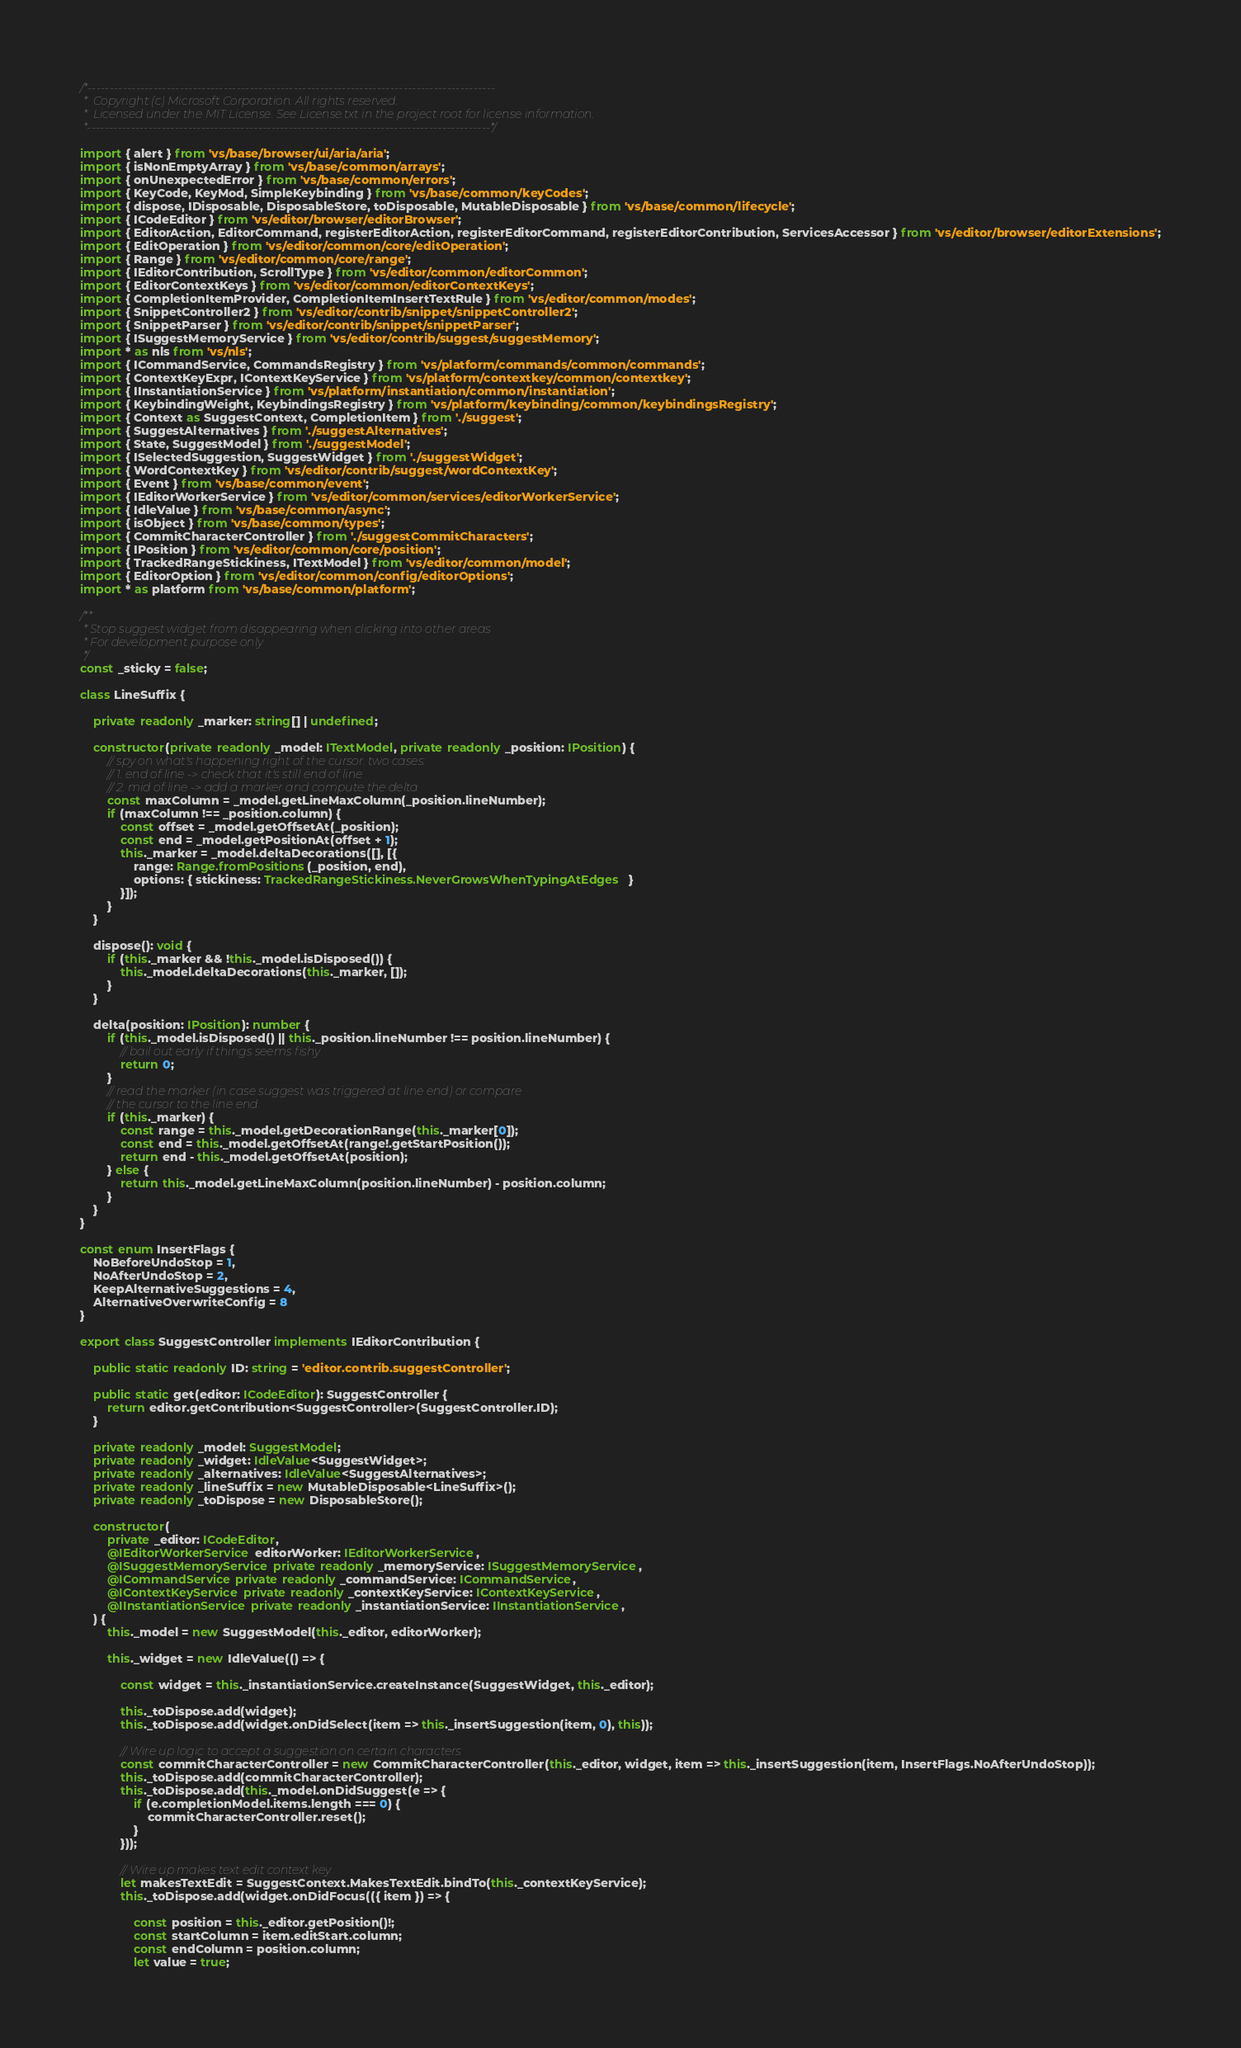<code> <loc_0><loc_0><loc_500><loc_500><_TypeScript_>/*---------------------------------------------------------------------------------------------
 *  Copyright (c) Microsoft Corporation. All rights reserved.
 *  Licensed under the MIT License. See License.txt in the project root for license information.
 *--------------------------------------------------------------------------------------------*/

import { alert } from 'vs/base/browser/ui/aria/aria';
import { isNonEmptyArray } from 'vs/base/common/arrays';
import { onUnexpectedError } from 'vs/base/common/errors';
import { KeyCode, KeyMod, SimpleKeybinding } from 'vs/base/common/keyCodes';
import { dispose, IDisposable, DisposableStore, toDisposable, MutableDisposable } from 'vs/base/common/lifecycle';
import { ICodeEditor } from 'vs/editor/browser/editorBrowser';
import { EditorAction, EditorCommand, registerEditorAction, registerEditorCommand, registerEditorContribution, ServicesAccessor } from 'vs/editor/browser/editorExtensions';
import { EditOperation } from 'vs/editor/common/core/editOperation';
import { Range } from 'vs/editor/common/core/range';
import { IEditorContribution, ScrollType } from 'vs/editor/common/editorCommon';
import { EditorContextKeys } from 'vs/editor/common/editorContextKeys';
import { CompletionItemProvider, CompletionItemInsertTextRule } from 'vs/editor/common/modes';
import { SnippetController2 } from 'vs/editor/contrib/snippet/snippetController2';
import { SnippetParser } from 'vs/editor/contrib/snippet/snippetParser';
import { ISuggestMemoryService } from 'vs/editor/contrib/suggest/suggestMemory';
import * as nls from 'vs/nls';
import { ICommandService, CommandsRegistry } from 'vs/platform/commands/common/commands';
import { ContextKeyExpr, IContextKeyService } from 'vs/platform/contextkey/common/contextkey';
import { IInstantiationService } from 'vs/platform/instantiation/common/instantiation';
import { KeybindingWeight, KeybindingsRegistry } from 'vs/platform/keybinding/common/keybindingsRegistry';
import { Context as SuggestContext, CompletionItem } from './suggest';
import { SuggestAlternatives } from './suggestAlternatives';
import { State, SuggestModel } from './suggestModel';
import { ISelectedSuggestion, SuggestWidget } from './suggestWidget';
import { WordContextKey } from 'vs/editor/contrib/suggest/wordContextKey';
import { Event } from 'vs/base/common/event';
import { IEditorWorkerService } from 'vs/editor/common/services/editorWorkerService';
import { IdleValue } from 'vs/base/common/async';
import { isObject } from 'vs/base/common/types';
import { CommitCharacterController } from './suggestCommitCharacters';
import { IPosition } from 'vs/editor/common/core/position';
import { TrackedRangeStickiness, ITextModel } from 'vs/editor/common/model';
import { EditorOption } from 'vs/editor/common/config/editorOptions';
import * as platform from 'vs/base/common/platform';

/**
 * Stop suggest widget from disappearing when clicking into other areas
 * For development purpose only
 */
const _sticky = false;

class LineSuffix {

	private readonly _marker: string[] | undefined;

	constructor(private readonly _model: ITextModel, private readonly _position: IPosition) {
		// spy on what's happening right of the cursor. two cases:
		// 1. end of line -> check that it's still end of line
		// 2. mid of line -> add a marker and compute the delta
		const maxColumn = _model.getLineMaxColumn(_position.lineNumber);
		if (maxColumn !== _position.column) {
			const offset = _model.getOffsetAt(_position);
			const end = _model.getPositionAt(offset + 1);
			this._marker = _model.deltaDecorations([], [{
				range: Range.fromPositions(_position, end),
				options: { stickiness: TrackedRangeStickiness.NeverGrowsWhenTypingAtEdges }
			}]);
		}
	}

	dispose(): void {
		if (this._marker && !this._model.isDisposed()) {
			this._model.deltaDecorations(this._marker, []);
		}
	}

	delta(position: IPosition): number {
		if (this._model.isDisposed() || this._position.lineNumber !== position.lineNumber) {
			// bail out early if things seems fishy
			return 0;
		}
		// read the marker (in case suggest was triggered at line end) or compare
		// the cursor to the line end.
		if (this._marker) {
			const range = this._model.getDecorationRange(this._marker[0]);
			const end = this._model.getOffsetAt(range!.getStartPosition());
			return end - this._model.getOffsetAt(position);
		} else {
			return this._model.getLineMaxColumn(position.lineNumber) - position.column;
		}
	}
}

const enum InsertFlags {
	NoBeforeUndoStop = 1,
	NoAfterUndoStop = 2,
	KeepAlternativeSuggestions = 4,
	AlternativeOverwriteConfig = 8
}

export class SuggestController implements IEditorContribution {

	public static readonly ID: string = 'editor.contrib.suggestController';

	public static get(editor: ICodeEditor): SuggestController {
		return editor.getContribution<SuggestController>(SuggestController.ID);
	}

	private readonly _model: SuggestModel;
	private readonly _widget: IdleValue<SuggestWidget>;
	private readonly _alternatives: IdleValue<SuggestAlternatives>;
	private readonly _lineSuffix = new MutableDisposable<LineSuffix>();
	private readonly _toDispose = new DisposableStore();

	constructor(
		private _editor: ICodeEditor,
		@IEditorWorkerService editorWorker: IEditorWorkerService,
		@ISuggestMemoryService private readonly _memoryService: ISuggestMemoryService,
		@ICommandService private readonly _commandService: ICommandService,
		@IContextKeyService private readonly _contextKeyService: IContextKeyService,
		@IInstantiationService private readonly _instantiationService: IInstantiationService,
	) {
		this._model = new SuggestModel(this._editor, editorWorker);

		this._widget = new IdleValue(() => {

			const widget = this._instantiationService.createInstance(SuggestWidget, this._editor);

			this._toDispose.add(widget);
			this._toDispose.add(widget.onDidSelect(item => this._insertSuggestion(item, 0), this));

			// Wire up logic to accept a suggestion on certain characters
			const commitCharacterController = new CommitCharacterController(this._editor, widget, item => this._insertSuggestion(item, InsertFlags.NoAfterUndoStop));
			this._toDispose.add(commitCharacterController);
			this._toDispose.add(this._model.onDidSuggest(e => {
				if (e.completionModel.items.length === 0) {
					commitCharacterController.reset();
				}
			}));

			// Wire up makes text edit context key
			let makesTextEdit = SuggestContext.MakesTextEdit.bindTo(this._contextKeyService);
			this._toDispose.add(widget.onDidFocus(({ item }) => {

				const position = this._editor.getPosition()!;
				const startColumn = item.editStart.column;
				const endColumn = position.column;
				let value = true;</code> 